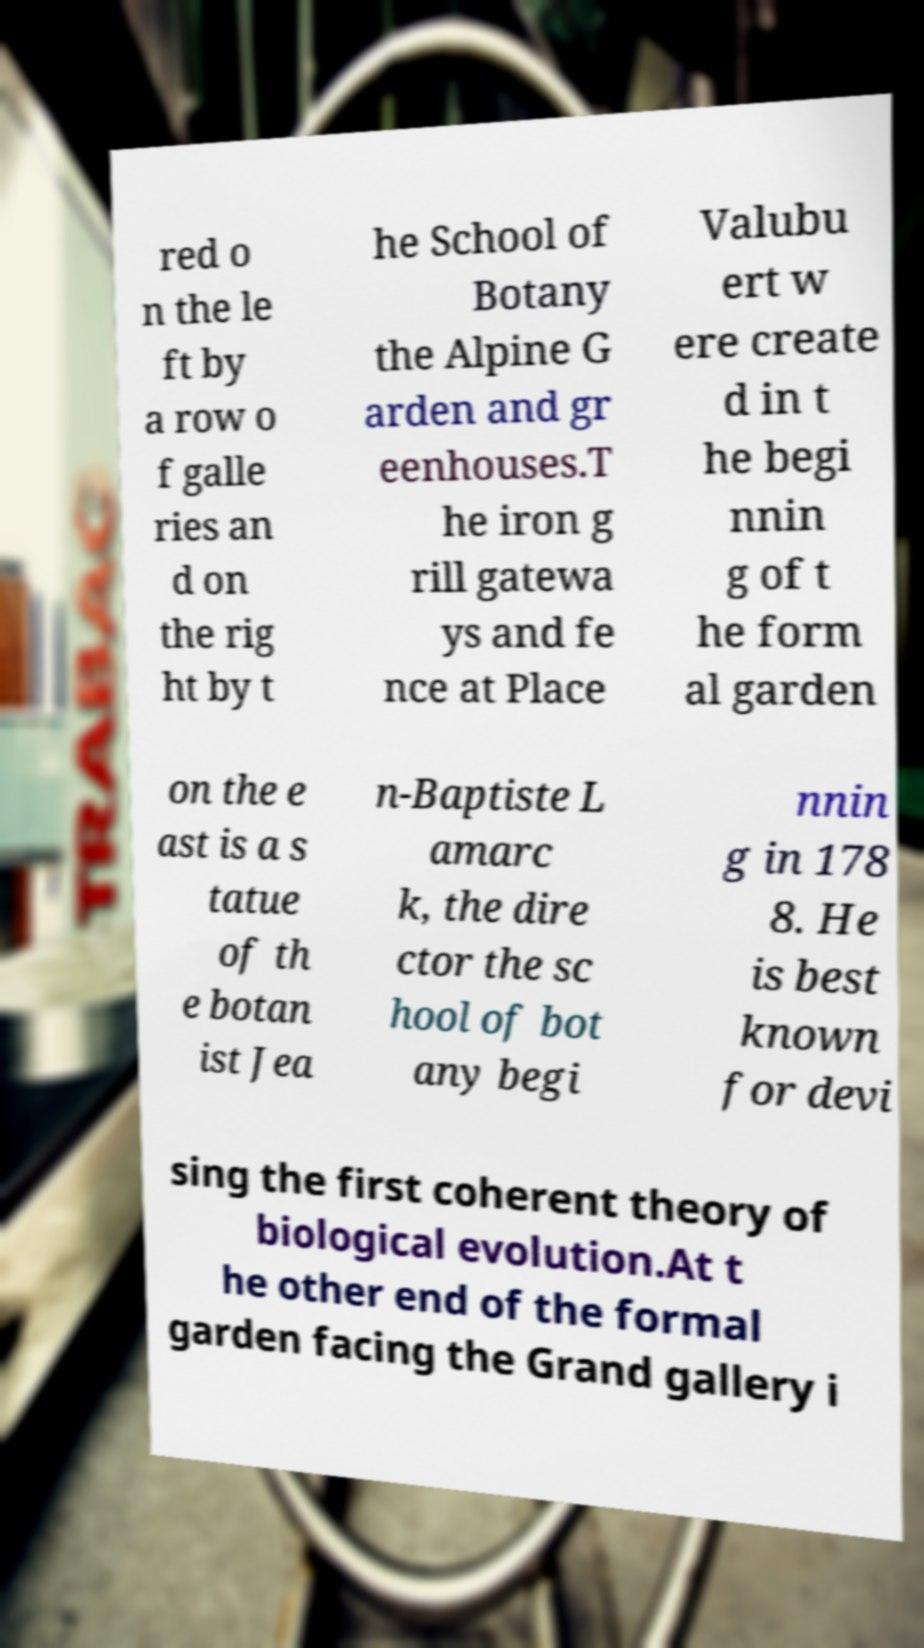I need the written content from this picture converted into text. Can you do that? red o n the le ft by a row o f galle ries an d on the rig ht by t he School of Botany the Alpine G arden and gr eenhouses.T he iron g rill gatewa ys and fe nce at Place Valubu ert w ere create d in t he begi nnin g of t he form al garden on the e ast is a s tatue of th e botan ist Jea n-Baptiste L amarc k, the dire ctor the sc hool of bot any begi nnin g in 178 8. He is best known for devi sing the first coherent theory of biological evolution.At t he other end of the formal garden facing the Grand gallery i 